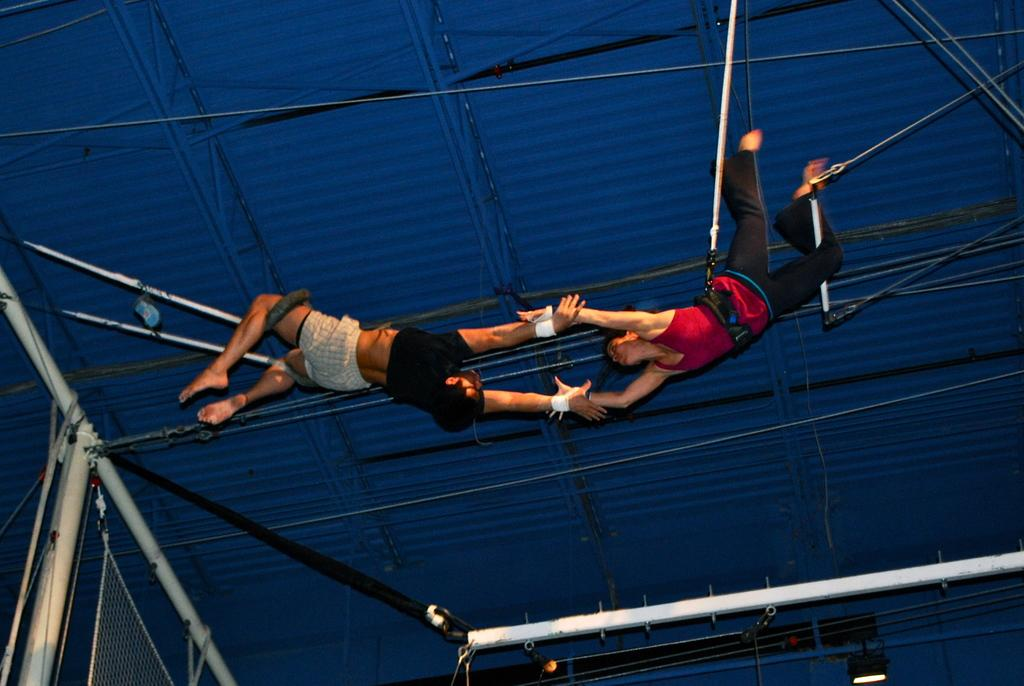What activity are the people in the image engaged in? The people in the image are performing gymnastics. How are they performing gymnastics? They are hanging from metal rods on the ceiling. What other gymnastics equipment can be seen in the image? There are metal poles visible in the image. What current is flowing through the metal poles in the image? There is no indication of electricity or current in the image; the metal poles are used for gymnastics purposes. 